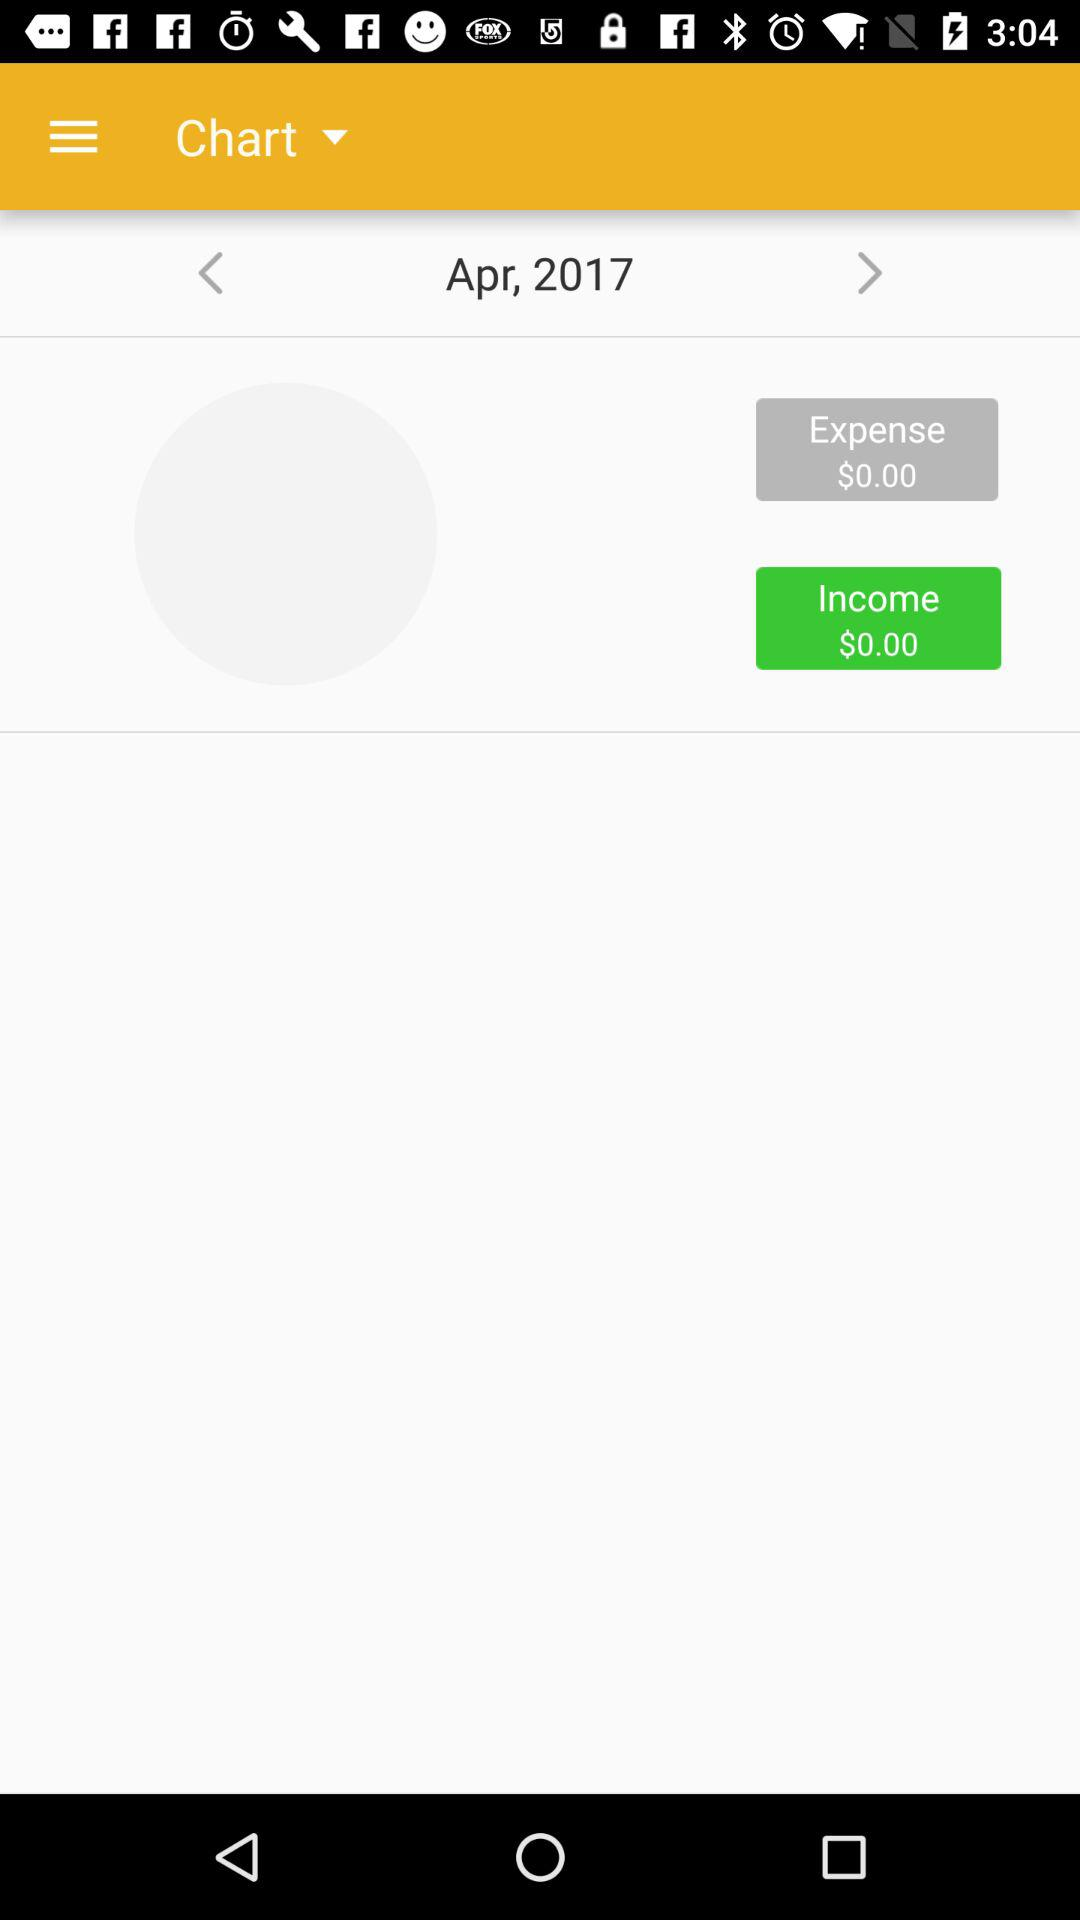What is the expense amount? The expense amount is $0.00. 